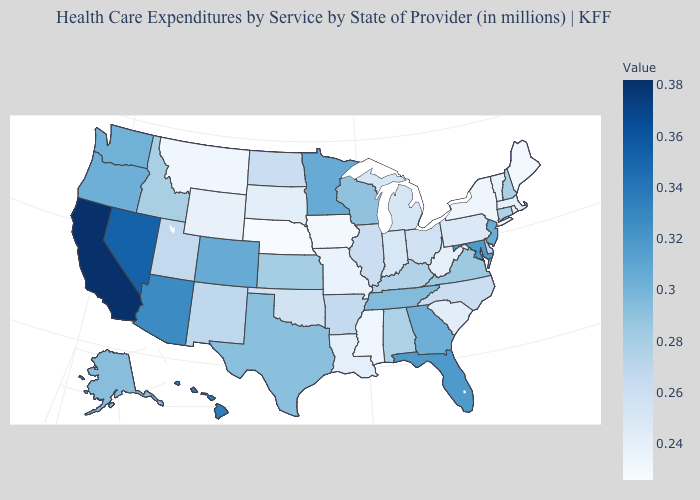Does New Mexico have a higher value than Massachusetts?
Quick response, please. Yes. Which states have the highest value in the USA?
Concise answer only. California. Does the map have missing data?
Short answer required. No. 